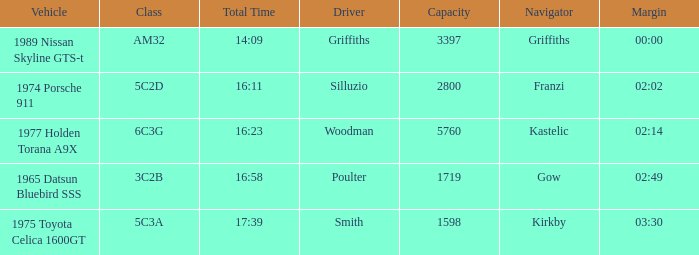What is the lowest capacity for the 1975 toyota celica 1600gt? 1598.0. 